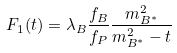Convert formula to latex. <formula><loc_0><loc_0><loc_500><loc_500>F _ { 1 } ( t ) = \lambda _ { B } \frac { f _ { B } } { f _ { P } } \frac { m _ { B ^ { * } } ^ { 2 } } { m _ { B ^ { * } } ^ { 2 } - t }</formula> 